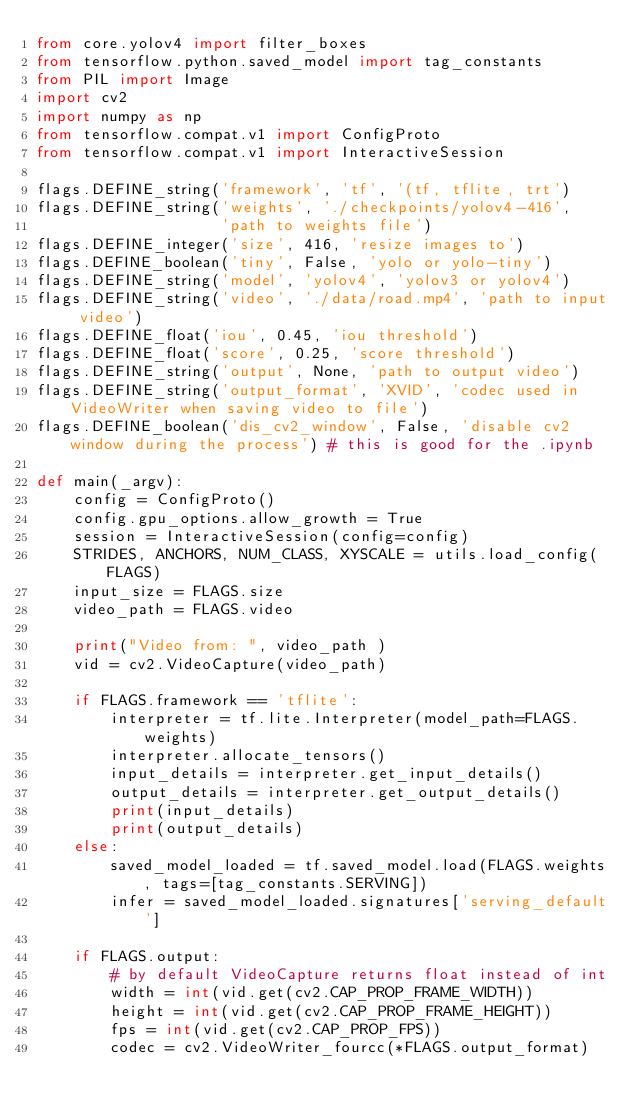Convert code to text. <code><loc_0><loc_0><loc_500><loc_500><_Python_>from core.yolov4 import filter_boxes
from tensorflow.python.saved_model import tag_constants
from PIL import Image
import cv2
import numpy as np
from tensorflow.compat.v1 import ConfigProto
from tensorflow.compat.v1 import InteractiveSession

flags.DEFINE_string('framework', 'tf', '(tf, tflite, trt')
flags.DEFINE_string('weights', './checkpoints/yolov4-416',
                    'path to weights file')
flags.DEFINE_integer('size', 416, 'resize images to')
flags.DEFINE_boolean('tiny', False, 'yolo or yolo-tiny')
flags.DEFINE_string('model', 'yolov4', 'yolov3 or yolov4')
flags.DEFINE_string('video', './data/road.mp4', 'path to input video')
flags.DEFINE_float('iou', 0.45, 'iou threshold')
flags.DEFINE_float('score', 0.25, 'score threshold')
flags.DEFINE_string('output', None, 'path to output video')
flags.DEFINE_string('output_format', 'XVID', 'codec used in VideoWriter when saving video to file')
flags.DEFINE_boolean('dis_cv2_window', False, 'disable cv2 window during the process') # this is good for the .ipynb

def main(_argv):
    config = ConfigProto()
    config.gpu_options.allow_growth = True
    session = InteractiveSession(config=config)
    STRIDES, ANCHORS, NUM_CLASS, XYSCALE = utils.load_config(FLAGS)
    input_size = FLAGS.size
    video_path = FLAGS.video

    print("Video from: ", video_path )
    vid = cv2.VideoCapture(video_path)

    if FLAGS.framework == 'tflite':
        interpreter = tf.lite.Interpreter(model_path=FLAGS.weights)
        interpreter.allocate_tensors()
        input_details = interpreter.get_input_details()
        output_details = interpreter.get_output_details()
        print(input_details)
        print(output_details)
    else:
        saved_model_loaded = tf.saved_model.load(FLAGS.weights, tags=[tag_constants.SERVING])
        infer = saved_model_loaded.signatures['serving_default']
    
    if FLAGS.output:
        # by default VideoCapture returns float instead of int
        width = int(vid.get(cv2.CAP_PROP_FRAME_WIDTH))
        height = int(vid.get(cv2.CAP_PROP_FRAME_HEIGHT))
        fps = int(vid.get(cv2.CAP_PROP_FPS))
        codec = cv2.VideoWriter_fourcc(*FLAGS.output_format)</code> 